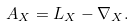<formula> <loc_0><loc_0><loc_500><loc_500>A _ { X } = L _ { X } - \nabla _ { X } .</formula> 